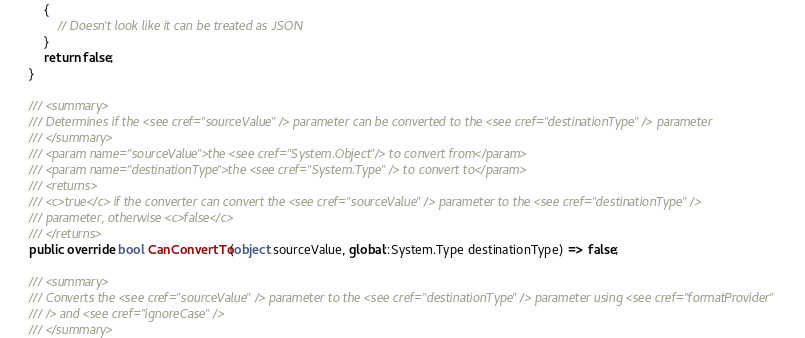<code> <loc_0><loc_0><loc_500><loc_500><_C#_>            {
                // Doesn't look like it can be treated as JSON
            }
            return false;
        }

        /// <summary>
        /// Determines if the <see cref="sourceValue" /> parameter can be converted to the <see cref="destinationType" /> parameter
        /// </summary>
        /// <param name="sourceValue">the <see cref="System.Object"/> to convert from</param>
        /// <param name="destinationType">the <see cref="System.Type" /> to convert to</param>
        /// <returns>
        /// <c>true</c> if the converter can convert the <see cref="sourceValue" /> parameter to the <see cref="destinationType" />
        /// parameter, otherwise <c>false</c>
        /// </returns>
        public override bool CanConvertTo(object sourceValue, global::System.Type destinationType) => false;

        /// <summary>
        /// Converts the <see cref="sourceValue" /> parameter to the <see cref="destinationType" /> parameter using <see cref="formatProvider"
        /// /> and <see cref="ignoreCase" />
        /// </summary></code> 